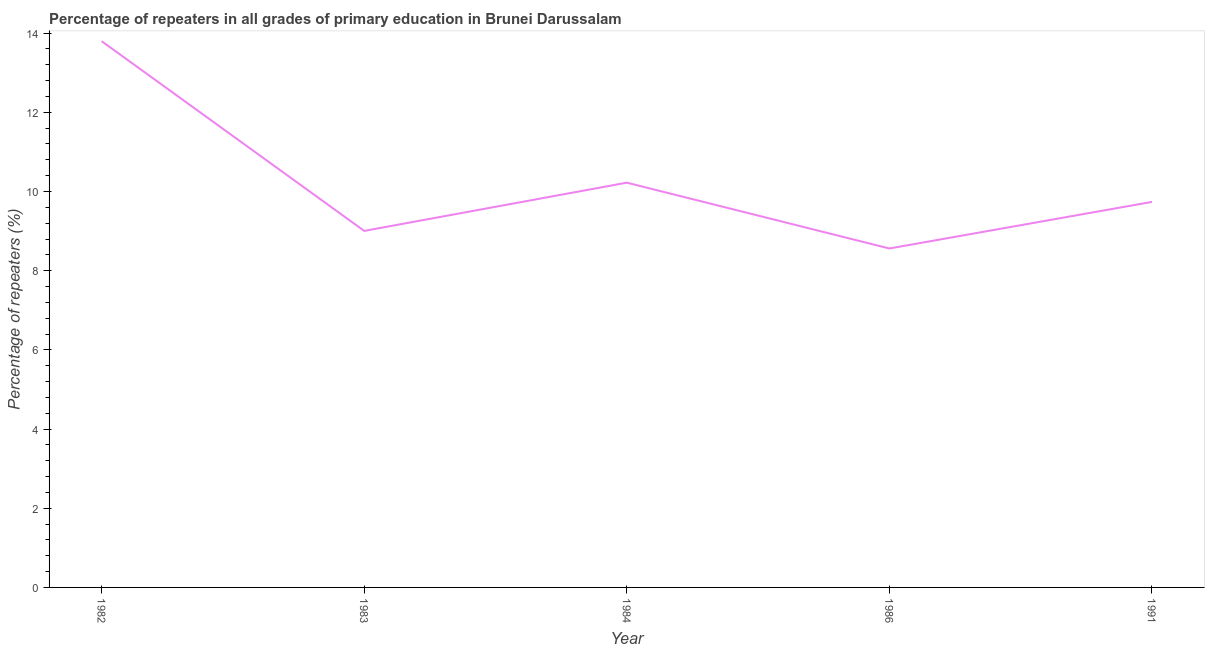What is the percentage of repeaters in primary education in 1991?
Ensure brevity in your answer.  9.74. Across all years, what is the maximum percentage of repeaters in primary education?
Provide a succinct answer. 13.8. Across all years, what is the minimum percentage of repeaters in primary education?
Offer a very short reply. 8.56. What is the sum of the percentage of repeaters in primary education?
Give a very brief answer. 51.32. What is the difference between the percentage of repeaters in primary education in 1984 and 1991?
Keep it short and to the point. 0.49. What is the average percentage of repeaters in primary education per year?
Give a very brief answer. 10.26. What is the median percentage of repeaters in primary education?
Make the answer very short. 9.74. What is the ratio of the percentage of repeaters in primary education in 1982 to that in 1986?
Make the answer very short. 1.61. Is the difference between the percentage of repeaters in primary education in 1983 and 1991 greater than the difference between any two years?
Your response must be concise. No. What is the difference between the highest and the second highest percentage of repeaters in primary education?
Make the answer very short. 3.57. Is the sum of the percentage of repeaters in primary education in 1983 and 1984 greater than the maximum percentage of repeaters in primary education across all years?
Offer a very short reply. Yes. What is the difference between the highest and the lowest percentage of repeaters in primary education?
Offer a terse response. 5.24. How many lines are there?
Ensure brevity in your answer.  1. How many years are there in the graph?
Provide a short and direct response. 5. What is the difference between two consecutive major ticks on the Y-axis?
Provide a succinct answer. 2. Are the values on the major ticks of Y-axis written in scientific E-notation?
Ensure brevity in your answer.  No. Does the graph contain any zero values?
Your response must be concise. No. What is the title of the graph?
Your answer should be very brief. Percentage of repeaters in all grades of primary education in Brunei Darussalam. What is the label or title of the X-axis?
Offer a very short reply. Year. What is the label or title of the Y-axis?
Your answer should be compact. Percentage of repeaters (%). What is the Percentage of repeaters (%) of 1982?
Offer a very short reply. 13.8. What is the Percentage of repeaters (%) in 1983?
Make the answer very short. 9. What is the Percentage of repeaters (%) in 1984?
Offer a very short reply. 10.22. What is the Percentage of repeaters (%) of 1986?
Keep it short and to the point. 8.56. What is the Percentage of repeaters (%) of 1991?
Ensure brevity in your answer.  9.74. What is the difference between the Percentage of repeaters (%) in 1982 and 1983?
Your answer should be very brief. 4.79. What is the difference between the Percentage of repeaters (%) in 1982 and 1984?
Offer a very short reply. 3.57. What is the difference between the Percentage of repeaters (%) in 1982 and 1986?
Offer a very short reply. 5.24. What is the difference between the Percentage of repeaters (%) in 1982 and 1991?
Ensure brevity in your answer.  4.06. What is the difference between the Percentage of repeaters (%) in 1983 and 1984?
Keep it short and to the point. -1.22. What is the difference between the Percentage of repeaters (%) in 1983 and 1986?
Your response must be concise. 0.44. What is the difference between the Percentage of repeaters (%) in 1983 and 1991?
Provide a succinct answer. -0.73. What is the difference between the Percentage of repeaters (%) in 1984 and 1986?
Ensure brevity in your answer.  1.66. What is the difference between the Percentage of repeaters (%) in 1984 and 1991?
Ensure brevity in your answer.  0.49. What is the difference between the Percentage of repeaters (%) in 1986 and 1991?
Give a very brief answer. -1.18. What is the ratio of the Percentage of repeaters (%) in 1982 to that in 1983?
Offer a terse response. 1.53. What is the ratio of the Percentage of repeaters (%) in 1982 to that in 1984?
Offer a terse response. 1.35. What is the ratio of the Percentage of repeaters (%) in 1982 to that in 1986?
Your response must be concise. 1.61. What is the ratio of the Percentage of repeaters (%) in 1982 to that in 1991?
Provide a short and direct response. 1.42. What is the ratio of the Percentage of repeaters (%) in 1983 to that in 1984?
Ensure brevity in your answer.  0.88. What is the ratio of the Percentage of repeaters (%) in 1983 to that in 1986?
Keep it short and to the point. 1.05. What is the ratio of the Percentage of repeaters (%) in 1983 to that in 1991?
Give a very brief answer. 0.93. What is the ratio of the Percentage of repeaters (%) in 1984 to that in 1986?
Your answer should be very brief. 1.19. What is the ratio of the Percentage of repeaters (%) in 1986 to that in 1991?
Keep it short and to the point. 0.88. 